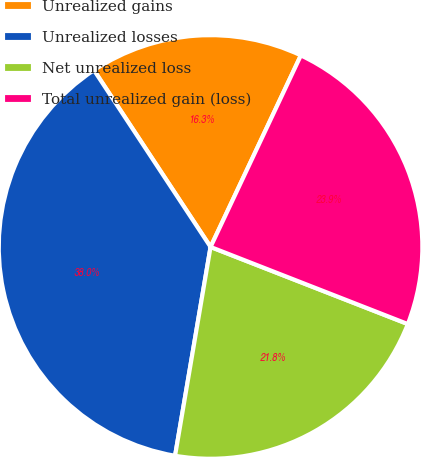Convert chart to OTSL. <chart><loc_0><loc_0><loc_500><loc_500><pie_chart><fcel>Unrealized gains<fcel>Unrealized losses<fcel>Net unrealized loss<fcel>Total unrealized gain (loss)<nl><fcel>16.29%<fcel>38.04%<fcel>21.75%<fcel>23.92%<nl></chart> 